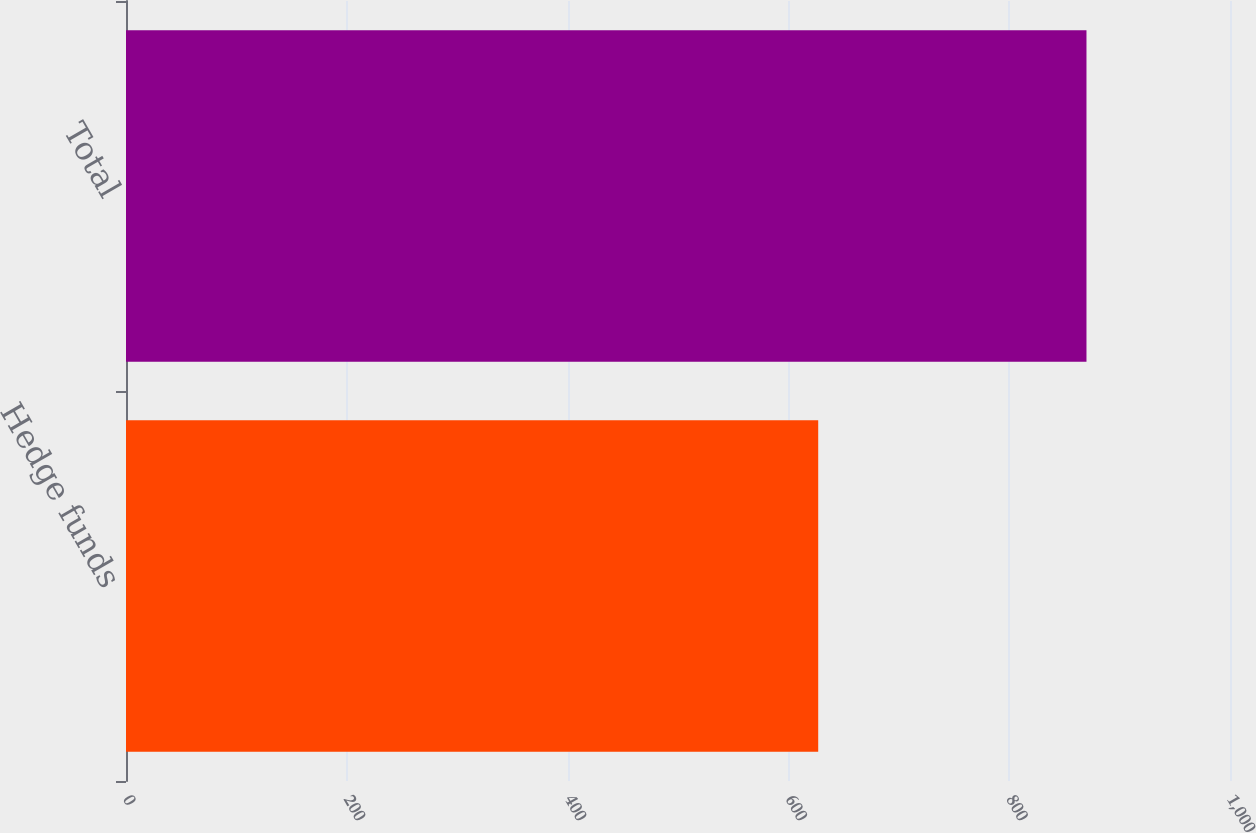<chart> <loc_0><loc_0><loc_500><loc_500><bar_chart><fcel>Hedge funds<fcel>Total<nl><fcel>627<fcel>870<nl></chart> 